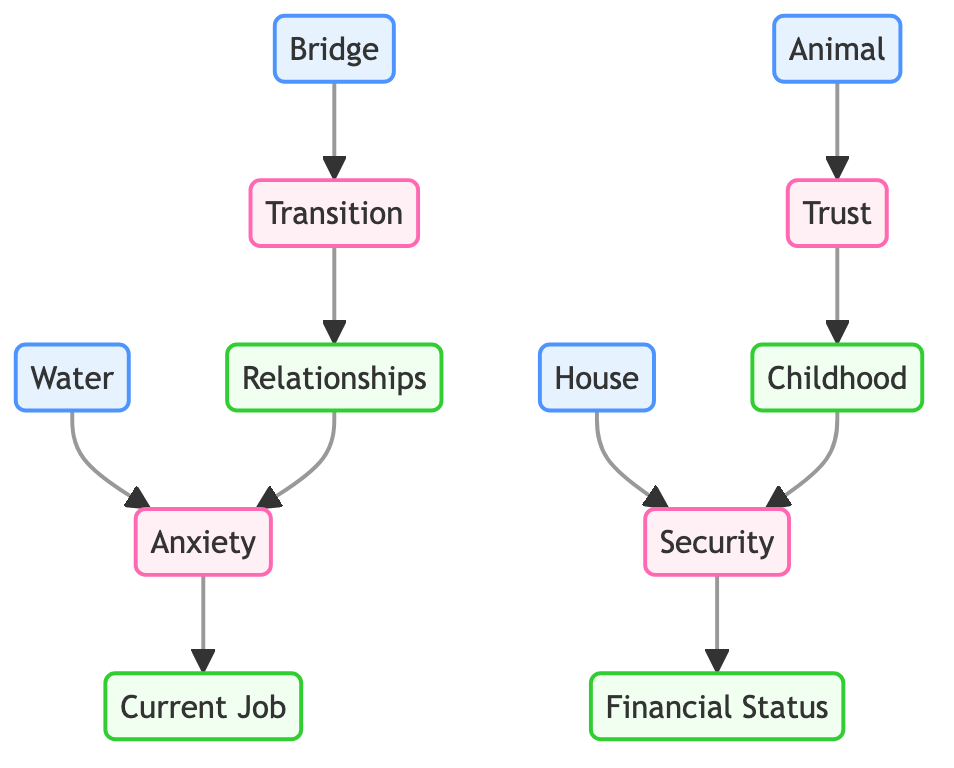What are the four dream symbols present in the diagram? The diagram identifies four dream symbols nodes: Water, Bridge, Animal, and House. Each of these represents a distinct visual element related to dreams.
Answer: Water, Bridge, Animal, House How many emotions are represented in the diagram? The diagram displays four emotion nodes: Anxiety, Transition, Security, and Trust. Therefore, the total count of emotion nodes is four.
Answer: Four Which dream symbol is connected to Anxiety? The connection from the dream symbols to emotions clearly shows that Water is linked to Anxiety, indicating a direct relationship.
Answer: Water What life event is associated with the emotion of Trust? The flow from the emotion symbols suggests that Trust is related to the Life Event of Childhood, directly indicating their association.
Answer: Childhood How many edges are there from the Emotional node Anxiety to life events? There is one edge directed from the Emotion Anxiety to the Life Event Current Job, which indicates one specific connection from this emotion to a life event.
Answer: One Which emotion leads to the Current Job life event? The directed flow from Anxiety clearly shows that this specific emotion is the one that leads to the life event labeled Current Job.
Answer: Anxiety Which life event connects with the emotion Transition? The connections illustrate that the emotion Transition is associated with the Life Event Relationships, marking that particular relationship.
Answer: Relationships What is the relationship between Childhood and Security? The diagram shows a bidirectional relationship: Childhood leads to the emotion Security, indicating that experiences during childhood can instill feelings of security.
Answer: Security Which dream symbol represents feelings of Security? The flow from dream symbols indicates that the House is directly linked to the emotion of Security, highlighting its representational significance.
Answer: House 